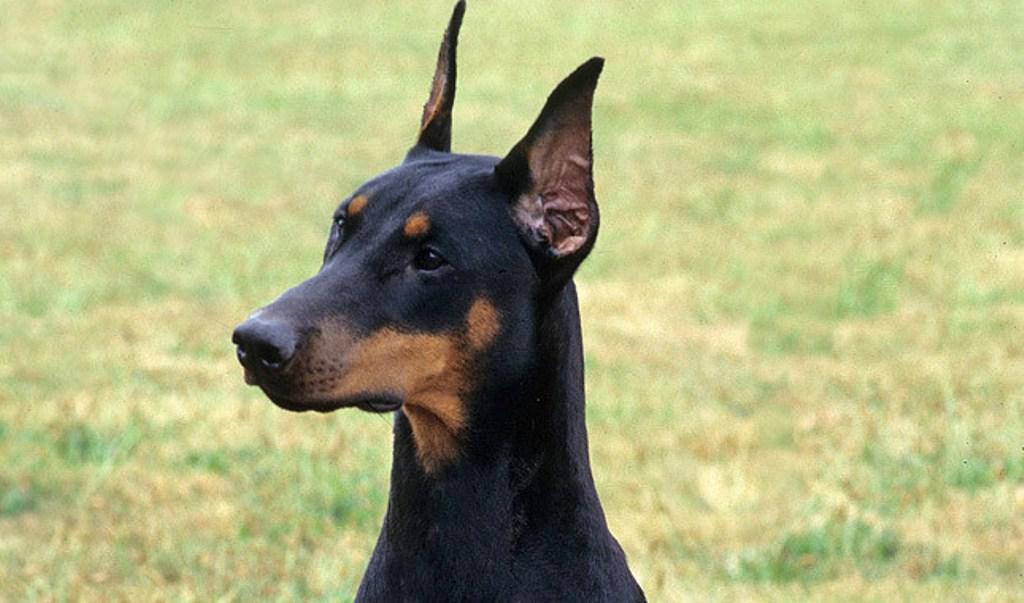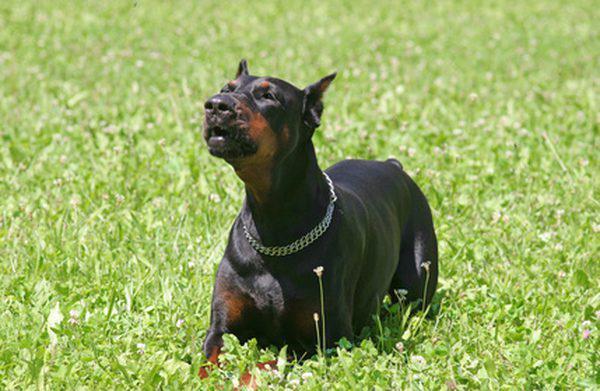The first image is the image on the left, the second image is the image on the right. Analyze the images presented: Is the assertion "One dog is reclining." valid? Answer yes or no. Yes. The first image is the image on the left, the second image is the image on the right. Examine the images to the left and right. Is the description "One image shows one pointy-eared doberman in a collar reclining on green ground, and the other image shows one leftward-facing doberman with a closed mouth and pointy ears." accurate? Answer yes or no. Yes. 